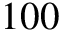<formula> <loc_0><loc_0><loc_500><loc_500>1 0 0</formula> 